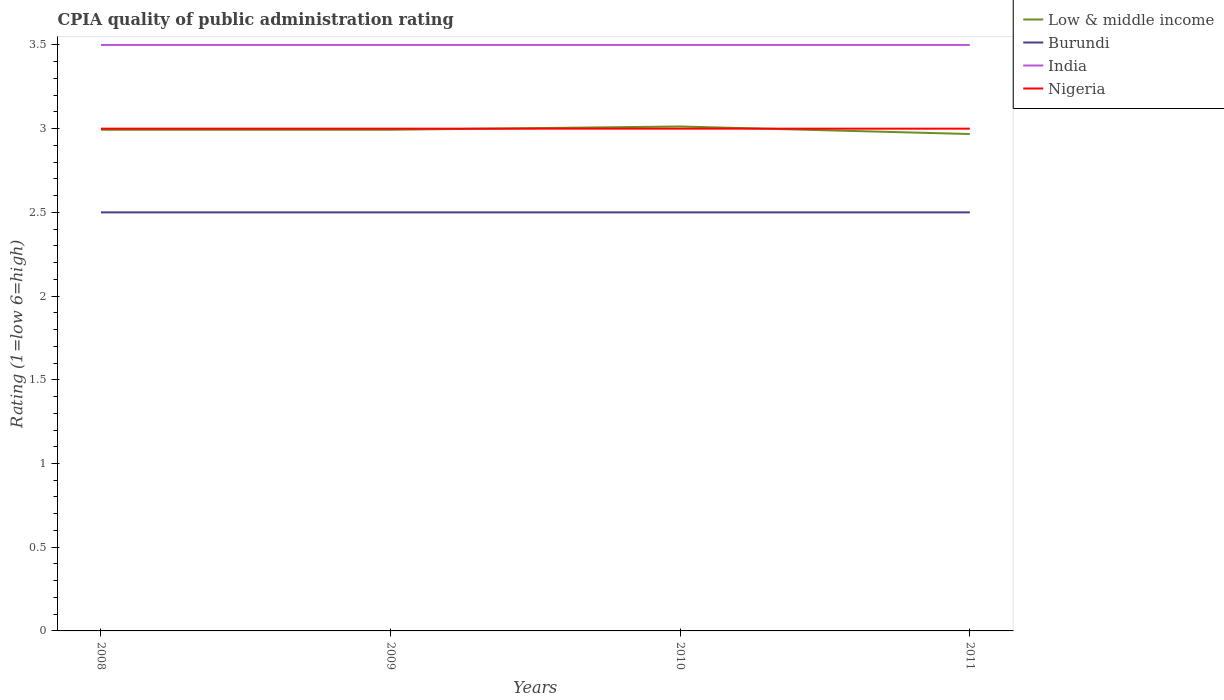How many different coloured lines are there?
Provide a succinct answer. 4. What is the total CPIA rating in Low & middle income in the graph?
Offer a very short reply. -0.02. What is the difference between the highest and the second highest CPIA rating in India?
Provide a short and direct response. 0. Is the CPIA rating in Nigeria strictly greater than the CPIA rating in Low & middle income over the years?
Keep it short and to the point. No. How many years are there in the graph?
Offer a very short reply. 4. Are the values on the major ticks of Y-axis written in scientific E-notation?
Your answer should be compact. No. Does the graph contain any zero values?
Your answer should be compact. No. Does the graph contain grids?
Offer a terse response. No. Where does the legend appear in the graph?
Ensure brevity in your answer.  Top right. How are the legend labels stacked?
Offer a terse response. Vertical. What is the title of the graph?
Offer a terse response. CPIA quality of public administration rating. Does "Kyrgyz Republic" appear as one of the legend labels in the graph?
Offer a very short reply. No. What is the Rating (1=low 6=high) in Low & middle income in 2008?
Provide a short and direct response. 2.99. What is the Rating (1=low 6=high) in Burundi in 2008?
Give a very brief answer. 2.5. What is the Rating (1=low 6=high) in Low & middle income in 2009?
Offer a terse response. 2.99. What is the Rating (1=low 6=high) of Burundi in 2009?
Your response must be concise. 2.5. What is the Rating (1=low 6=high) in Nigeria in 2009?
Offer a terse response. 3. What is the Rating (1=low 6=high) in Low & middle income in 2010?
Offer a terse response. 3.01. What is the Rating (1=low 6=high) in Burundi in 2010?
Keep it short and to the point. 2.5. What is the Rating (1=low 6=high) of Nigeria in 2010?
Make the answer very short. 3. What is the Rating (1=low 6=high) of Low & middle income in 2011?
Your response must be concise. 2.97. What is the Rating (1=low 6=high) of Burundi in 2011?
Your answer should be compact. 2.5. What is the Rating (1=low 6=high) in India in 2011?
Keep it short and to the point. 3.5. Across all years, what is the maximum Rating (1=low 6=high) of Low & middle income?
Your answer should be compact. 3.01. Across all years, what is the maximum Rating (1=low 6=high) of Burundi?
Your answer should be compact. 2.5. Across all years, what is the maximum Rating (1=low 6=high) in India?
Make the answer very short. 3.5. Across all years, what is the maximum Rating (1=low 6=high) of Nigeria?
Provide a succinct answer. 3. Across all years, what is the minimum Rating (1=low 6=high) of Low & middle income?
Provide a succinct answer. 2.97. Across all years, what is the minimum Rating (1=low 6=high) of Burundi?
Give a very brief answer. 2.5. Across all years, what is the minimum Rating (1=low 6=high) in Nigeria?
Give a very brief answer. 3. What is the total Rating (1=low 6=high) in Low & middle income in the graph?
Give a very brief answer. 11.97. What is the total Rating (1=low 6=high) in India in the graph?
Your answer should be compact. 14. What is the difference between the Rating (1=low 6=high) of Low & middle income in 2008 and that in 2009?
Your response must be concise. -0. What is the difference between the Rating (1=low 6=high) of Burundi in 2008 and that in 2009?
Ensure brevity in your answer.  0. What is the difference between the Rating (1=low 6=high) of Nigeria in 2008 and that in 2009?
Your response must be concise. 0. What is the difference between the Rating (1=low 6=high) of Low & middle income in 2008 and that in 2010?
Provide a succinct answer. -0.02. What is the difference between the Rating (1=low 6=high) in Burundi in 2008 and that in 2010?
Ensure brevity in your answer.  0. What is the difference between the Rating (1=low 6=high) in Low & middle income in 2008 and that in 2011?
Offer a terse response. 0.03. What is the difference between the Rating (1=low 6=high) of India in 2008 and that in 2011?
Your answer should be very brief. 0. What is the difference between the Rating (1=low 6=high) of Low & middle income in 2009 and that in 2010?
Offer a very short reply. -0.02. What is the difference between the Rating (1=low 6=high) of Burundi in 2009 and that in 2010?
Offer a very short reply. 0. What is the difference between the Rating (1=low 6=high) in Nigeria in 2009 and that in 2010?
Your answer should be compact. 0. What is the difference between the Rating (1=low 6=high) of Low & middle income in 2009 and that in 2011?
Provide a succinct answer. 0.03. What is the difference between the Rating (1=low 6=high) in Burundi in 2009 and that in 2011?
Your response must be concise. 0. What is the difference between the Rating (1=low 6=high) of Low & middle income in 2010 and that in 2011?
Provide a short and direct response. 0.04. What is the difference between the Rating (1=low 6=high) of Burundi in 2010 and that in 2011?
Give a very brief answer. 0. What is the difference between the Rating (1=low 6=high) of Low & middle income in 2008 and the Rating (1=low 6=high) of Burundi in 2009?
Ensure brevity in your answer.  0.49. What is the difference between the Rating (1=low 6=high) of Low & middle income in 2008 and the Rating (1=low 6=high) of India in 2009?
Ensure brevity in your answer.  -0.51. What is the difference between the Rating (1=low 6=high) in Low & middle income in 2008 and the Rating (1=low 6=high) in Nigeria in 2009?
Your answer should be compact. -0.01. What is the difference between the Rating (1=low 6=high) of Burundi in 2008 and the Rating (1=low 6=high) of Nigeria in 2009?
Provide a short and direct response. -0.5. What is the difference between the Rating (1=low 6=high) of India in 2008 and the Rating (1=low 6=high) of Nigeria in 2009?
Provide a succinct answer. 0.5. What is the difference between the Rating (1=low 6=high) of Low & middle income in 2008 and the Rating (1=low 6=high) of Burundi in 2010?
Offer a terse response. 0.49. What is the difference between the Rating (1=low 6=high) in Low & middle income in 2008 and the Rating (1=low 6=high) in India in 2010?
Give a very brief answer. -0.51. What is the difference between the Rating (1=low 6=high) of Low & middle income in 2008 and the Rating (1=low 6=high) of Nigeria in 2010?
Ensure brevity in your answer.  -0.01. What is the difference between the Rating (1=low 6=high) in Burundi in 2008 and the Rating (1=low 6=high) in India in 2010?
Ensure brevity in your answer.  -1. What is the difference between the Rating (1=low 6=high) in Low & middle income in 2008 and the Rating (1=low 6=high) in Burundi in 2011?
Your response must be concise. 0.49. What is the difference between the Rating (1=low 6=high) of Low & middle income in 2008 and the Rating (1=low 6=high) of India in 2011?
Provide a succinct answer. -0.51. What is the difference between the Rating (1=low 6=high) in Low & middle income in 2008 and the Rating (1=low 6=high) in Nigeria in 2011?
Ensure brevity in your answer.  -0.01. What is the difference between the Rating (1=low 6=high) of Low & middle income in 2009 and the Rating (1=low 6=high) of Burundi in 2010?
Offer a very short reply. 0.49. What is the difference between the Rating (1=low 6=high) in Low & middle income in 2009 and the Rating (1=low 6=high) in India in 2010?
Offer a very short reply. -0.51. What is the difference between the Rating (1=low 6=high) in Low & middle income in 2009 and the Rating (1=low 6=high) in Nigeria in 2010?
Provide a succinct answer. -0.01. What is the difference between the Rating (1=low 6=high) in Burundi in 2009 and the Rating (1=low 6=high) in Nigeria in 2010?
Give a very brief answer. -0.5. What is the difference between the Rating (1=low 6=high) in Low & middle income in 2009 and the Rating (1=low 6=high) in Burundi in 2011?
Your answer should be very brief. 0.49. What is the difference between the Rating (1=low 6=high) in Low & middle income in 2009 and the Rating (1=low 6=high) in India in 2011?
Your response must be concise. -0.51. What is the difference between the Rating (1=low 6=high) in Low & middle income in 2009 and the Rating (1=low 6=high) in Nigeria in 2011?
Your response must be concise. -0.01. What is the difference between the Rating (1=low 6=high) of Burundi in 2009 and the Rating (1=low 6=high) of India in 2011?
Ensure brevity in your answer.  -1. What is the difference between the Rating (1=low 6=high) in India in 2009 and the Rating (1=low 6=high) in Nigeria in 2011?
Provide a succinct answer. 0.5. What is the difference between the Rating (1=low 6=high) of Low & middle income in 2010 and the Rating (1=low 6=high) of Burundi in 2011?
Offer a terse response. 0.51. What is the difference between the Rating (1=low 6=high) of Low & middle income in 2010 and the Rating (1=low 6=high) of India in 2011?
Your response must be concise. -0.49. What is the difference between the Rating (1=low 6=high) in Low & middle income in 2010 and the Rating (1=low 6=high) in Nigeria in 2011?
Your answer should be compact. 0.01. What is the difference between the Rating (1=low 6=high) in Burundi in 2010 and the Rating (1=low 6=high) in India in 2011?
Your response must be concise. -1. What is the average Rating (1=low 6=high) of Low & middle income per year?
Provide a short and direct response. 2.99. What is the average Rating (1=low 6=high) of Burundi per year?
Your response must be concise. 2.5. What is the average Rating (1=low 6=high) in Nigeria per year?
Keep it short and to the point. 3. In the year 2008, what is the difference between the Rating (1=low 6=high) in Low & middle income and Rating (1=low 6=high) in Burundi?
Keep it short and to the point. 0.49. In the year 2008, what is the difference between the Rating (1=low 6=high) in Low & middle income and Rating (1=low 6=high) in India?
Your answer should be very brief. -0.51. In the year 2008, what is the difference between the Rating (1=low 6=high) in Low & middle income and Rating (1=low 6=high) in Nigeria?
Offer a terse response. -0.01. In the year 2008, what is the difference between the Rating (1=low 6=high) in Burundi and Rating (1=low 6=high) in India?
Offer a terse response. -1. In the year 2009, what is the difference between the Rating (1=low 6=high) in Low & middle income and Rating (1=low 6=high) in Burundi?
Provide a short and direct response. 0.49. In the year 2009, what is the difference between the Rating (1=low 6=high) in Low & middle income and Rating (1=low 6=high) in India?
Keep it short and to the point. -0.51. In the year 2009, what is the difference between the Rating (1=low 6=high) of Low & middle income and Rating (1=low 6=high) of Nigeria?
Your answer should be compact. -0.01. In the year 2009, what is the difference between the Rating (1=low 6=high) in India and Rating (1=low 6=high) in Nigeria?
Make the answer very short. 0.5. In the year 2010, what is the difference between the Rating (1=low 6=high) in Low & middle income and Rating (1=low 6=high) in Burundi?
Keep it short and to the point. 0.51. In the year 2010, what is the difference between the Rating (1=low 6=high) in Low & middle income and Rating (1=low 6=high) in India?
Provide a short and direct response. -0.49. In the year 2010, what is the difference between the Rating (1=low 6=high) of Low & middle income and Rating (1=low 6=high) of Nigeria?
Provide a short and direct response. 0.01. In the year 2011, what is the difference between the Rating (1=low 6=high) in Low & middle income and Rating (1=low 6=high) in Burundi?
Give a very brief answer. 0.47. In the year 2011, what is the difference between the Rating (1=low 6=high) of Low & middle income and Rating (1=low 6=high) of India?
Provide a succinct answer. -0.53. In the year 2011, what is the difference between the Rating (1=low 6=high) in Low & middle income and Rating (1=low 6=high) in Nigeria?
Your answer should be very brief. -0.03. In the year 2011, what is the difference between the Rating (1=low 6=high) in Burundi and Rating (1=low 6=high) in India?
Provide a short and direct response. -1. In the year 2011, what is the difference between the Rating (1=low 6=high) of Burundi and Rating (1=low 6=high) of Nigeria?
Your answer should be compact. -0.5. In the year 2011, what is the difference between the Rating (1=low 6=high) in India and Rating (1=low 6=high) in Nigeria?
Make the answer very short. 0.5. What is the ratio of the Rating (1=low 6=high) of Low & middle income in 2008 to that in 2009?
Your response must be concise. 1. What is the ratio of the Rating (1=low 6=high) of India in 2008 to that in 2009?
Give a very brief answer. 1. What is the ratio of the Rating (1=low 6=high) of Nigeria in 2008 to that in 2009?
Provide a succinct answer. 1. What is the ratio of the Rating (1=low 6=high) in Burundi in 2008 to that in 2010?
Ensure brevity in your answer.  1. What is the ratio of the Rating (1=low 6=high) of India in 2008 to that in 2010?
Keep it short and to the point. 1. What is the ratio of the Rating (1=low 6=high) in Low & middle income in 2008 to that in 2011?
Your response must be concise. 1.01. What is the ratio of the Rating (1=low 6=high) of Low & middle income in 2009 to that in 2010?
Provide a short and direct response. 0.99. What is the ratio of the Rating (1=low 6=high) of Low & middle income in 2009 to that in 2011?
Your response must be concise. 1.01. What is the ratio of the Rating (1=low 6=high) of India in 2009 to that in 2011?
Offer a very short reply. 1. What is the ratio of the Rating (1=low 6=high) in Low & middle income in 2010 to that in 2011?
Provide a short and direct response. 1.02. What is the ratio of the Rating (1=low 6=high) of Nigeria in 2010 to that in 2011?
Your answer should be very brief. 1. What is the difference between the highest and the second highest Rating (1=low 6=high) in Low & middle income?
Provide a short and direct response. 0.02. What is the difference between the highest and the second highest Rating (1=low 6=high) in Burundi?
Offer a terse response. 0. What is the difference between the highest and the lowest Rating (1=low 6=high) of Low & middle income?
Give a very brief answer. 0.04. What is the difference between the highest and the lowest Rating (1=low 6=high) of Burundi?
Your answer should be very brief. 0. 